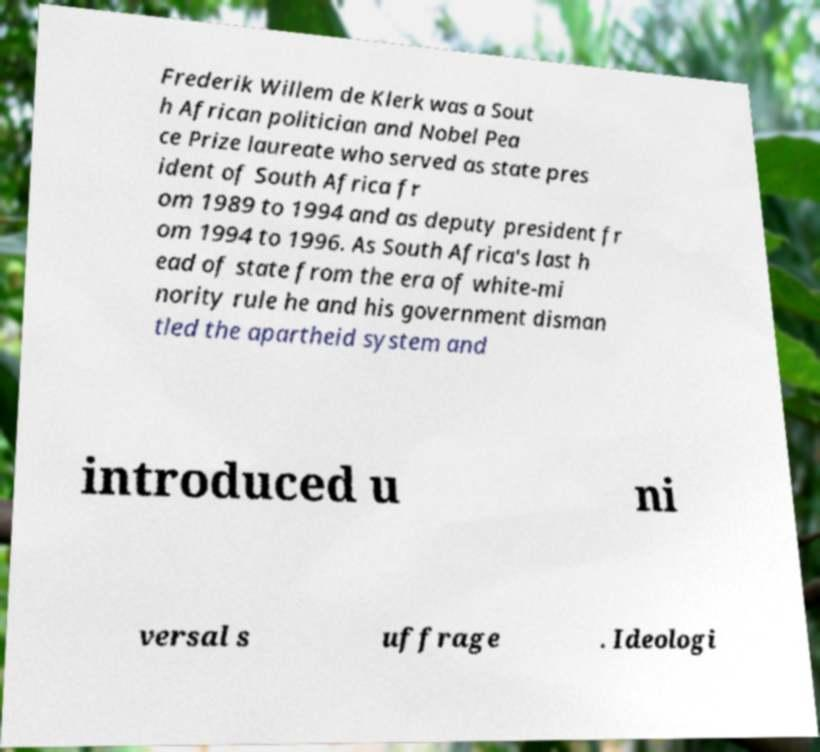Can you accurately transcribe the text from the provided image for me? Frederik Willem de Klerk was a Sout h African politician and Nobel Pea ce Prize laureate who served as state pres ident of South Africa fr om 1989 to 1994 and as deputy president fr om 1994 to 1996. As South Africa's last h ead of state from the era of white-mi nority rule he and his government disman tled the apartheid system and introduced u ni versal s uffrage . Ideologi 